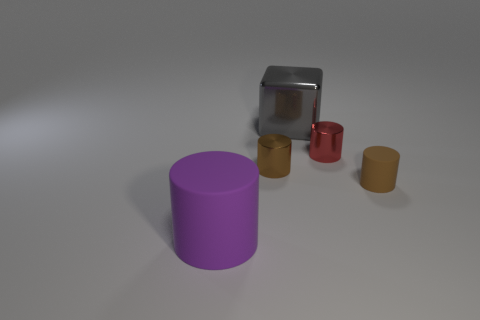Are there any rubber objects to the right of the gray metal cube?
Provide a short and direct response. Yes. What is the color of the tiny matte object that is the same shape as the small red shiny thing?
Ensure brevity in your answer.  Brown. Is there any other thing that has the same shape as the large rubber object?
Make the answer very short. Yes. What material is the purple cylinder on the left side of the large gray thing?
Your answer should be compact. Rubber. There is a purple thing that is the same shape as the red thing; what is its size?
Provide a short and direct response. Large. How many other big cubes are the same material as the gray cube?
Keep it short and to the point. 0. What number of big matte cylinders are the same color as the large metal block?
Offer a very short reply. 0. What number of objects are big rubber objects that are in front of the big gray shiny cube or objects that are right of the big rubber cylinder?
Ensure brevity in your answer.  5. Are there fewer tiny brown metal cylinders that are right of the red metallic cylinder than tiny red metallic spheres?
Ensure brevity in your answer.  No. Is there a shiny object of the same size as the brown rubber cylinder?
Your answer should be compact. Yes. 